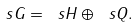Convert formula to latex. <formula><loc_0><loc_0><loc_500><loc_500>\ s G = \ s H \oplus \ s Q .</formula> 